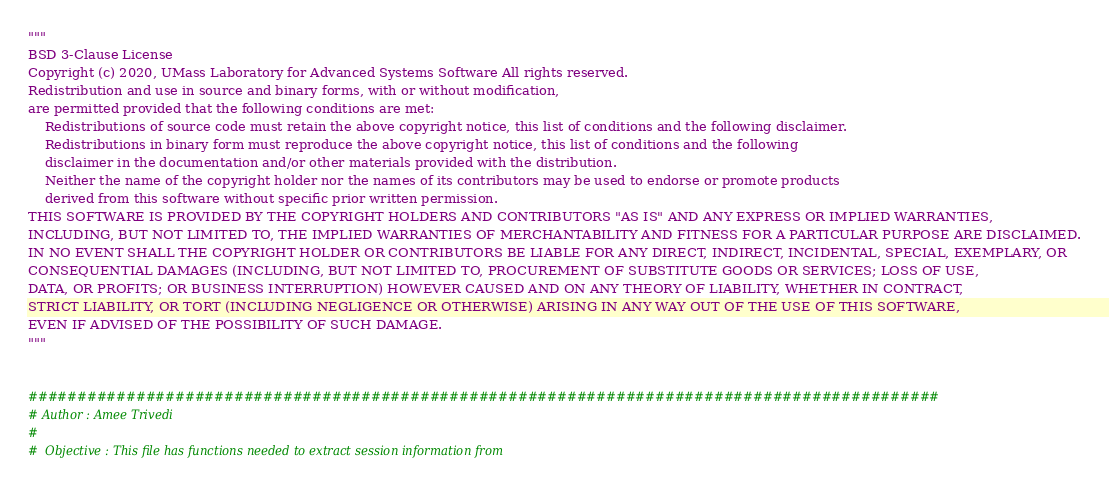<code> <loc_0><loc_0><loc_500><loc_500><_Python_>"""
BSD 3-Clause License
Copyright (c) 2020, UMass Laboratory for Advanced Systems Software All rights reserved.
Redistribution and use in source and binary forms, with or without modification,
are permitted provided that the following conditions are met:
    Redistributions of source code must retain the above copyright notice, this list of conditions and the following disclaimer.
    Redistributions in binary form must reproduce the above copyright notice, this list of conditions and the following
    disclaimer in the documentation and/or other materials provided with the distribution.
    Neither the name of the copyright holder nor the names of its contributors may be used to endorse or promote products
    derived from this software without specific prior written permission.
THIS SOFTWARE IS PROVIDED BY THE COPYRIGHT HOLDERS AND CONTRIBUTORS "AS IS" AND ANY EXPRESS OR IMPLIED WARRANTIES,
INCLUDING, BUT NOT LIMITED TO, THE IMPLIED WARRANTIES OF MERCHANTABILITY AND FITNESS FOR A PARTICULAR PURPOSE ARE DISCLAIMED.
IN NO EVENT SHALL THE COPYRIGHT HOLDER OR CONTRIBUTORS BE LIABLE FOR ANY DIRECT, INDIRECT, INCIDENTAL, SPECIAL, EXEMPLARY, OR
CONSEQUENTIAL DAMAGES (INCLUDING, BUT NOT LIMITED TO, PROCUREMENT OF SUBSTITUTE GOODS OR SERVICES; LOSS OF USE,
DATA, OR PROFITS; OR BUSINESS INTERRUPTION) HOWEVER CAUSED AND ON ANY THEORY OF LIABILITY, WHETHER IN CONTRACT,
STRICT LIABILITY, OR TORT (INCLUDING NEGLIGENCE OR OTHERWISE) ARISING IN ANY WAY OUT OF THE USE OF THIS SOFTWARE,
EVEN IF ADVISED OF THE POSSIBILITY OF SUCH DAMAGE.
"""


#############################################################################################
# Author : Amee Trivedi
#
#  Objective : This file has functions needed to extract session information from</code> 